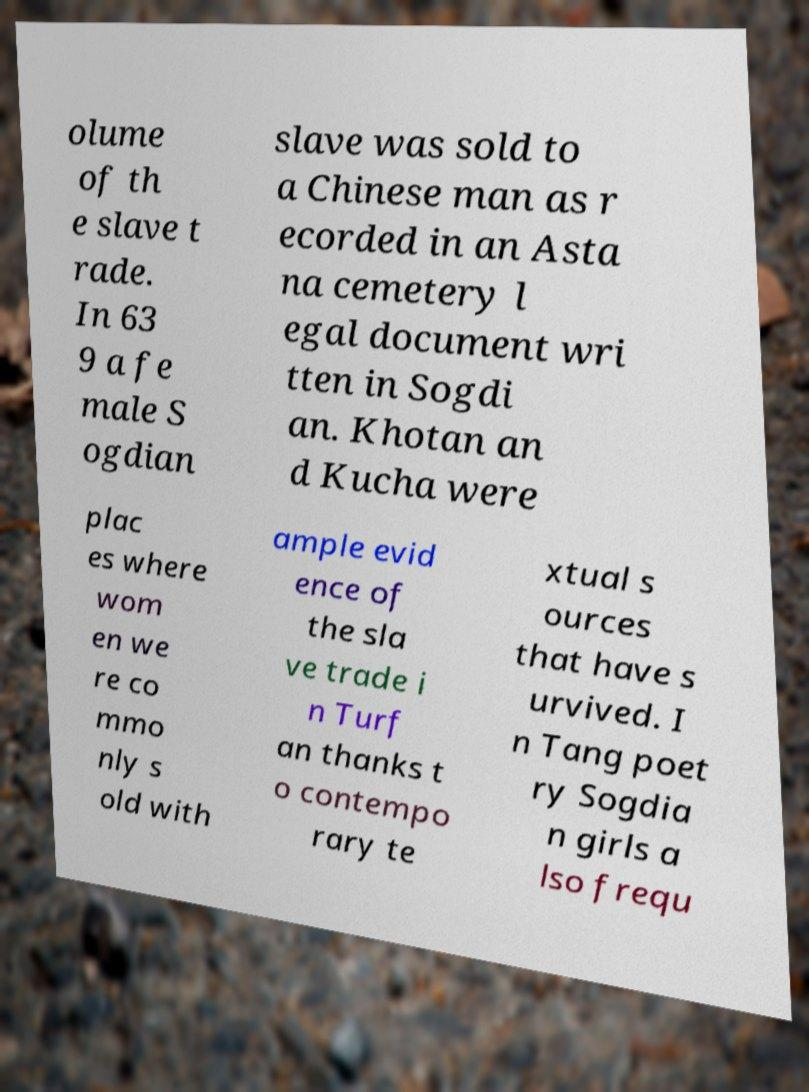Could you extract and type out the text from this image? olume of th e slave t rade. In 63 9 a fe male S ogdian slave was sold to a Chinese man as r ecorded in an Asta na cemetery l egal document wri tten in Sogdi an. Khotan an d Kucha were plac es where wom en we re co mmo nly s old with ample evid ence of the sla ve trade i n Turf an thanks t o contempo rary te xtual s ources that have s urvived. I n Tang poet ry Sogdia n girls a lso frequ 